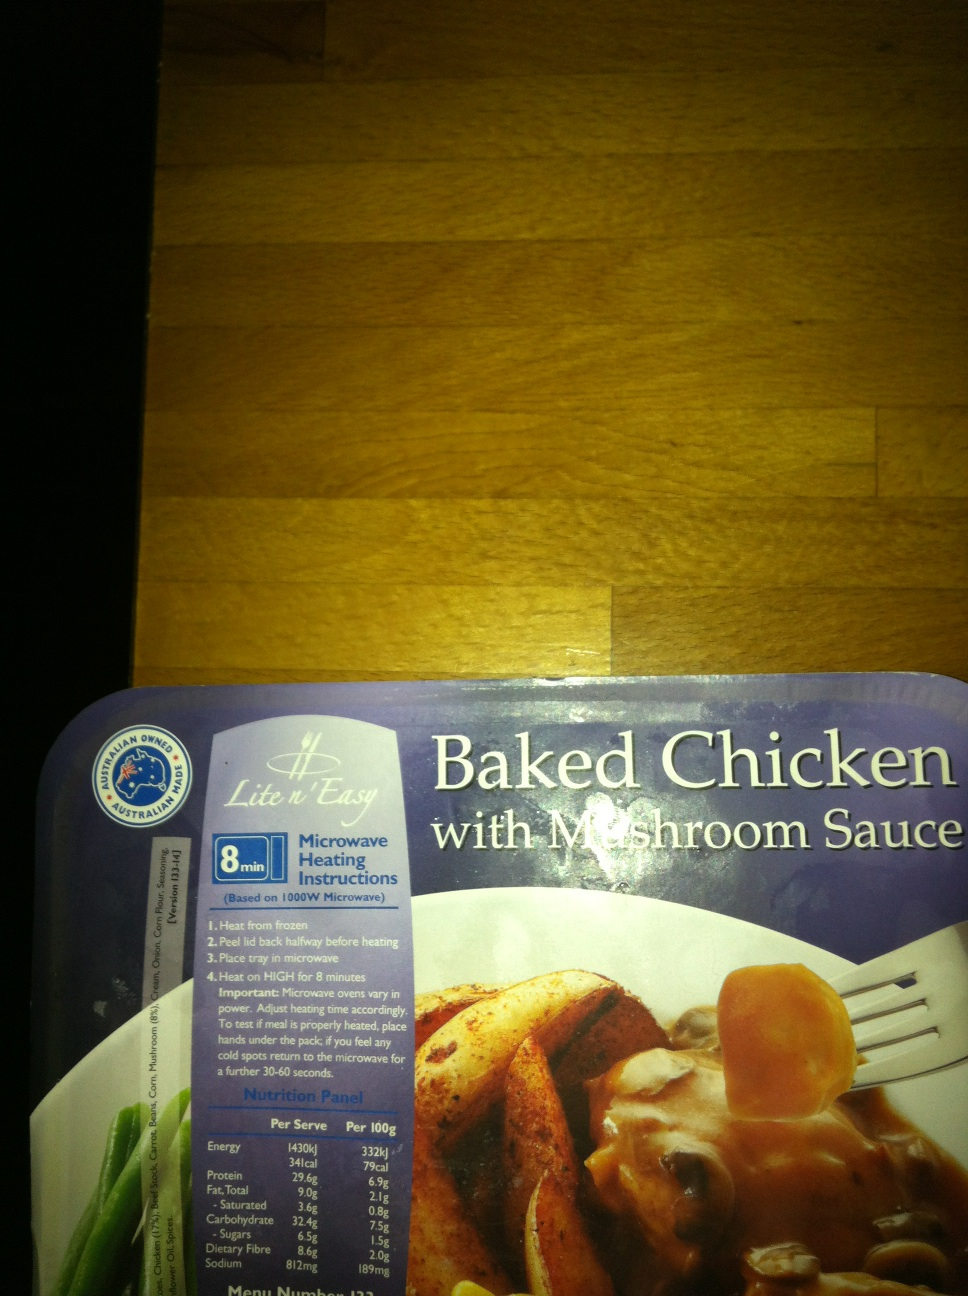Can you tell me more about the microwave instructions provided on the box? The microwave instructions on the box advise heating the meal directly from frozen. You should peel back the lid halfway before heating, place the tray in the microwave, and heat on HIGH for 8 minutes. It's important to stir once mid-heating and test the meal to ensure it is properly heated before serving. 